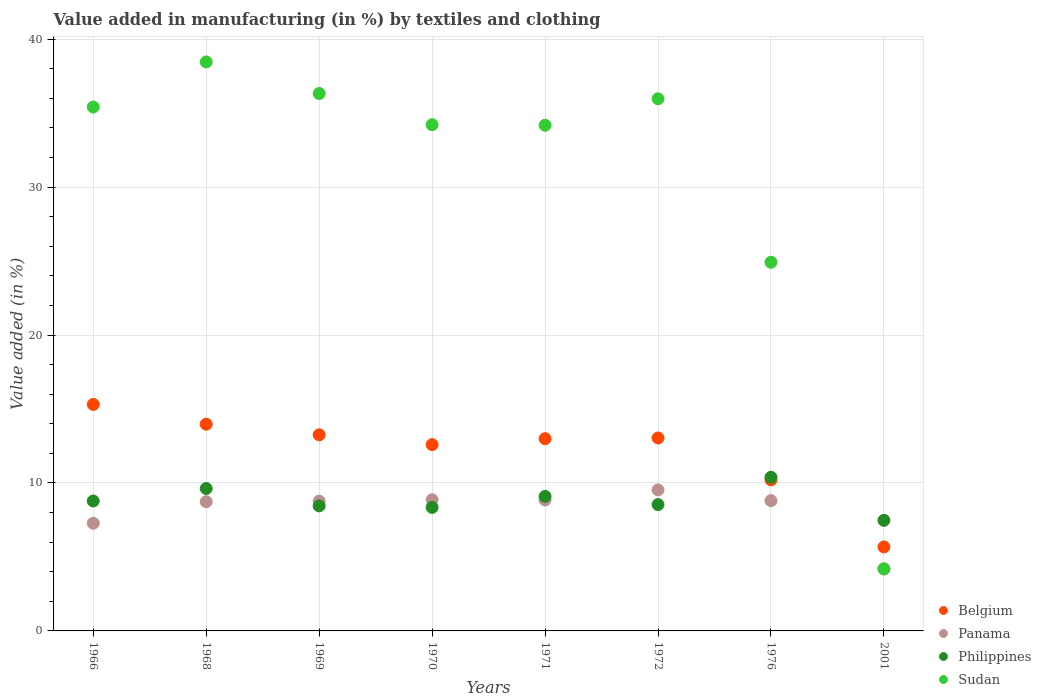What is the percentage of value added in manufacturing by textiles and clothing in Panama in 1970?
Make the answer very short. 8.87. Across all years, what is the maximum percentage of value added in manufacturing by textiles and clothing in Sudan?
Your answer should be very brief. 38.46. Across all years, what is the minimum percentage of value added in manufacturing by textiles and clothing in Belgium?
Your answer should be very brief. 5.68. In which year was the percentage of value added in manufacturing by textiles and clothing in Belgium maximum?
Provide a succinct answer. 1966. In which year was the percentage of value added in manufacturing by textiles and clothing in Sudan minimum?
Provide a short and direct response. 2001. What is the total percentage of value added in manufacturing by textiles and clothing in Philippines in the graph?
Keep it short and to the point. 70.7. What is the difference between the percentage of value added in manufacturing by textiles and clothing in Philippines in 1970 and that in 2001?
Provide a short and direct response. 0.88. What is the difference between the percentage of value added in manufacturing by textiles and clothing in Sudan in 1976 and the percentage of value added in manufacturing by textiles and clothing in Panama in 1970?
Your answer should be very brief. 16.05. What is the average percentage of value added in manufacturing by textiles and clothing in Philippines per year?
Provide a succinct answer. 8.84. In the year 1968, what is the difference between the percentage of value added in manufacturing by textiles and clothing in Panama and percentage of value added in manufacturing by textiles and clothing in Belgium?
Offer a very short reply. -5.24. In how many years, is the percentage of value added in manufacturing by textiles and clothing in Philippines greater than 16 %?
Offer a very short reply. 0. What is the ratio of the percentage of value added in manufacturing by textiles and clothing in Philippines in 1968 to that in 1969?
Make the answer very short. 1.14. Is the percentage of value added in manufacturing by textiles and clothing in Belgium in 1970 less than that in 1971?
Provide a succinct answer. Yes. Is the difference between the percentage of value added in manufacturing by textiles and clothing in Panama in 1968 and 2001 greater than the difference between the percentage of value added in manufacturing by textiles and clothing in Belgium in 1968 and 2001?
Ensure brevity in your answer.  No. What is the difference between the highest and the second highest percentage of value added in manufacturing by textiles and clothing in Belgium?
Provide a short and direct response. 1.33. What is the difference between the highest and the lowest percentage of value added in manufacturing by textiles and clothing in Philippines?
Provide a succinct answer. 2.91. In how many years, is the percentage of value added in manufacturing by textiles and clothing in Belgium greater than the average percentage of value added in manufacturing by textiles and clothing in Belgium taken over all years?
Your answer should be very brief. 6. Is it the case that in every year, the sum of the percentage of value added in manufacturing by textiles and clothing in Sudan and percentage of value added in manufacturing by textiles and clothing in Belgium  is greater than the sum of percentage of value added in manufacturing by textiles and clothing in Panama and percentage of value added in manufacturing by textiles and clothing in Philippines?
Make the answer very short. No. Is it the case that in every year, the sum of the percentage of value added in manufacturing by textiles and clothing in Sudan and percentage of value added in manufacturing by textiles and clothing in Panama  is greater than the percentage of value added in manufacturing by textiles and clothing in Philippines?
Your response must be concise. Yes. Is the percentage of value added in manufacturing by textiles and clothing in Philippines strictly greater than the percentage of value added in manufacturing by textiles and clothing in Belgium over the years?
Keep it short and to the point. No. Is the percentage of value added in manufacturing by textiles and clothing in Panama strictly less than the percentage of value added in manufacturing by textiles and clothing in Philippines over the years?
Provide a short and direct response. No. How many dotlines are there?
Offer a terse response. 4. Are the values on the major ticks of Y-axis written in scientific E-notation?
Make the answer very short. No. What is the title of the graph?
Give a very brief answer. Value added in manufacturing (in %) by textiles and clothing. Does "Netherlands" appear as one of the legend labels in the graph?
Offer a terse response. No. What is the label or title of the Y-axis?
Provide a succinct answer. Value added (in %). What is the Value added (in %) of Belgium in 1966?
Provide a succinct answer. 15.31. What is the Value added (in %) of Panama in 1966?
Provide a succinct answer. 7.28. What is the Value added (in %) in Philippines in 1966?
Provide a short and direct response. 8.78. What is the Value added (in %) of Sudan in 1966?
Your answer should be very brief. 35.41. What is the Value added (in %) of Belgium in 1968?
Provide a short and direct response. 13.97. What is the Value added (in %) in Panama in 1968?
Provide a succinct answer. 8.73. What is the Value added (in %) in Philippines in 1968?
Your answer should be compact. 9.63. What is the Value added (in %) of Sudan in 1968?
Make the answer very short. 38.46. What is the Value added (in %) in Belgium in 1969?
Provide a succinct answer. 13.26. What is the Value added (in %) of Panama in 1969?
Ensure brevity in your answer.  8.77. What is the Value added (in %) of Philippines in 1969?
Offer a terse response. 8.45. What is the Value added (in %) of Sudan in 1969?
Give a very brief answer. 36.32. What is the Value added (in %) of Belgium in 1970?
Ensure brevity in your answer.  12.59. What is the Value added (in %) in Panama in 1970?
Offer a very short reply. 8.87. What is the Value added (in %) in Philippines in 1970?
Keep it short and to the point. 8.35. What is the Value added (in %) in Sudan in 1970?
Keep it short and to the point. 34.21. What is the Value added (in %) in Belgium in 1971?
Provide a short and direct response. 12.99. What is the Value added (in %) in Panama in 1971?
Provide a succinct answer. 8.85. What is the Value added (in %) in Philippines in 1971?
Provide a succinct answer. 9.09. What is the Value added (in %) of Sudan in 1971?
Provide a short and direct response. 34.18. What is the Value added (in %) in Belgium in 1972?
Provide a short and direct response. 13.04. What is the Value added (in %) of Panama in 1972?
Offer a terse response. 9.53. What is the Value added (in %) in Philippines in 1972?
Ensure brevity in your answer.  8.54. What is the Value added (in %) of Sudan in 1972?
Offer a very short reply. 35.97. What is the Value added (in %) of Belgium in 1976?
Your response must be concise. 10.22. What is the Value added (in %) in Panama in 1976?
Offer a terse response. 8.8. What is the Value added (in %) in Philippines in 1976?
Offer a very short reply. 10.39. What is the Value added (in %) of Sudan in 1976?
Provide a short and direct response. 24.92. What is the Value added (in %) of Belgium in 2001?
Your response must be concise. 5.68. What is the Value added (in %) of Panama in 2001?
Keep it short and to the point. 4.19. What is the Value added (in %) of Philippines in 2001?
Your answer should be very brief. 7.47. What is the Value added (in %) of Sudan in 2001?
Your answer should be very brief. 4.19. Across all years, what is the maximum Value added (in %) of Belgium?
Make the answer very short. 15.31. Across all years, what is the maximum Value added (in %) in Panama?
Give a very brief answer. 9.53. Across all years, what is the maximum Value added (in %) in Philippines?
Your answer should be very brief. 10.39. Across all years, what is the maximum Value added (in %) of Sudan?
Your answer should be very brief. 38.46. Across all years, what is the minimum Value added (in %) in Belgium?
Your answer should be compact. 5.68. Across all years, what is the minimum Value added (in %) in Panama?
Your response must be concise. 4.19. Across all years, what is the minimum Value added (in %) of Philippines?
Make the answer very short. 7.47. Across all years, what is the minimum Value added (in %) in Sudan?
Your answer should be compact. 4.19. What is the total Value added (in %) in Belgium in the graph?
Your answer should be compact. 97.06. What is the total Value added (in %) in Panama in the graph?
Make the answer very short. 65.02. What is the total Value added (in %) of Philippines in the graph?
Ensure brevity in your answer.  70.7. What is the total Value added (in %) in Sudan in the graph?
Your answer should be very brief. 243.67. What is the difference between the Value added (in %) in Belgium in 1966 and that in 1968?
Offer a terse response. 1.33. What is the difference between the Value added (in %) in Panama in 1966 and that in 1968?
Your answer should be very brief. -1.45. What is the difference between the Value added (in %) of Philippines in 1966 and that in 1968?
Keep it short and to the point. -0.84. What is the difference between the Value added (in %) of Sudan in 1966 and that in 1968?
Your answer should be very brief. -3.05. What is the difference between the Value added (in %) in Belgium in 1966 and that in 1969?
Offer a terse response. 2.05. What is the difference between the Value added (in %) in Panama in 1966 and that in 1969?
Provide a succinct answer. -1.49. What is the difference between the Value added (in %) of Philippines in 1966 and that in 1969?
Offer a terse response. 0.33. What is the difference between the Value added (in %) of Sudan in 1966 and that in 1969?
Offer a terse response. -0.92. What is the difference between the Value added (in %) of Belgium in 1966 and that in 1970?
Provide a short and direct response. 2.72. What is the difference between the Value added (in %) of Panama in 1966 and that in 1970?
Offer a very short reply. -1.59. What is the difference between the Value added (in %) in Philippines in 1966 and that in 1970?
Make the answer very short. 0.43. What is the difference between the Value added (in %) in Sudan in 1966 and that in 1970?
Your answer should be very brief. 1.19. What is the difference between the Value added (in %) in Belgium in 1966 and that in 1971?
Provide a succinct answer. 2.31. What is the difference between the Value added (in %) in Panama in 1966 and that in 1971?
Your response must be concise. -1.57. What is the difference between the Value added (in %) of Philippines in 1966 and that in 1971?
Make the answer very short. -0.31. What is the difference between the Value added (in %) of Sudan in 1966 and that in 1971?
Make the answer very short. 1.23. What is the difference between the Value added (in %) in Belgium in 1966 and that in 1972?
Give a very brief answer. 2.27. What is the difference between the Value added (in %) of Panama in 1966 and that in 1972?
Keep it short and to the point. -2.26. What is the difference between the Value added (in %) in Philippines in 1966 and that in 1972?
Make the answer very short. 0.24. What is the difference between the Value added (in %) of Sudan in 1966 and that in 1972?
Provide a short and direct response. -0.56. What is the difference between the Value added (in %) in Belgium in 1966 and that in 1976?
Ensure brevity in your answer.  5.09. What is the difference between the Value added (in %) in Panama in 1966 and that in 1976?
Your answer should be very brief. -1.53. What is the difference between the Value added (in %) in Philippines in 1966 and that in 1976?
Your response must be concise. -1.61. What is the difference between the Value added (in %) in Sudan in 1966 and that in 1976?
Keep it short and to the point. 10.49. What is the difference between the Value added (in %) in Belgium in 1966 and that in 2001?
Ensure brevity in your answer.  9.63. What is the difference between the Value added (in %) of Panama in 1966 and that in 2001?
Offer a terse response. 3.09. What is the difference between the Value added (in %) in Philippines in 1966 and that in 2001?
Ensure brevity in your answer.  1.31. What is the difference between the Value added (in %) of Sudan in 1966 and that in 2001?
Give a very brief answer. 31.22. What is the difference between the Value added (in %) of Belgium in 1968 and that in 1969?
Keep it short and to the point. 0.72. What is the difference between the Value added (in %) in Panama in 1968 and that in 1969?
Your answer should be compact. -0.04. What is the difference between the Value added (in %) of Philippines in 1968 and that in 1969?
Keep it short and to the point. 1.17. What is the difference between the Value added (in %) of Sudan in 1968 and that in 1969?
Keep it short and to the point. 2.14. What is the difference between the Value added (in %) in Belgium in 1968 and that in 1970?
Your answer should be very brief. 1.38. What is the difference between the Value added (in %) in Panama in 1968 and that in 1970?
Your answer should be compact. -0.14. What is the difference between the Value added (in %) in Philippines in 1968 and that in 1970?
Keep it short and to the point. 1.28. What is the difference between the Value added (in %) in Sudan in 1968 and that in 1970?
Ensure brevity in your answer.  4.24. What is the difference between the Value added (in %) in Belgium in 1968 and that in 1971?
Offer a terse response. 0.98. What is the difference between the Value added (in %) in Panama in 1968 and that in 1971?
Make the answer very short. -0.12. What is the difference between the Value added (in %) in Philippines in 1968 and that in 1971?
Your answer should be compact. 0.53. What is the difference between the Value added (in %) of Sudan in 1968 and that in 1971?
Offer a very short reply. 4.28. What is the difference between the Value added (in %) in Belgium in 1968 and that in 1972?
Provide a succinct answer. 0.93. What is the difference between the Value added (in %) of Panama in 1968 and that in 1972?
Your response must be concise. -0.8. What is the difference between the Value added (in %) in Philippines in 1968 and that in 1972?
Your response must be concise. 1.09. What is the difference between the Value added (in %) in Sudan in 1968 and that in 1972?
Ensure brevity in your answer.  2.49. What is the difference between the Value added (in %) of Belgium in 1968 and that in 1976?
Ensure brevity in your answer.  3.76. What is the difference between the Value added (in %) in Panama in 1968 and that in 1976?
Offer a terse response. -0.07. What is the difference between the Value added (in %) of Philippines in 1968 and that in 1976?
Keep it short and to the point. -0.76. What is the difference between the Value added (in %) of Sudan in 1968 and that in 1976?
Your answer should be very brief. 13.54. What is the difference between the Value added (in %) in Belgium in 1968 and that in 2001?
Ensure brevity in your answer.  8.3. What is the difference between the Value added (in %) in Panama in 1968 and that in 2001?
Provide a short and direct response. 4.54. What is the difference between the Value added (in %) of Philippines in 1968 and that in 2001?
Your answer should be compact. 2.15. What is the difference between the Value added (in %) of Sudan in 1968 and that in 2001?
Your response must be concise. 34.27. What is the difference between the Value added (in %) in Belgium in 1969 and that in 1970?
Make the answer very short. 0.66. What is the difference between the Value added (in %) in Panama in 1969 and that in 1970?
Ensure brevity in your answer.  -0.1. What is the difference between the Value added (in %) of Philippines in 1969 and that in 1970?
Offer a terse response. 0.1. What is the difference between the Value added (in %) in Sudan in 1969 and that in 1970?
Keep it short and to the point. 2.11. What is the difference between the Value added (in %) in Belgium in 1969 and that in 1971?
Give a very brief answer. 0.26. What is the difference between the Value added (in %) of Panama in 1969 and that in 1971?
Make the answer very short. -0.08. What is the difference between the Value added (in %) in Philippines in 1969 and that in 1971?
Your answer should be compact. -0.64. What is the difference between the Value added (in %) in Sudan in 1969 and that in 1971?
Offer a terse response. 2.14. What is the difference between the Value added (in %) in Belgium in 1969 and that in 1972?
Ensure brevity in your answer.  0.22. What is the difference between the Value added (in %) in Panama in 1969 and that in 1972?
Provide a succinct answer. -0.76. What is the difference between the Value added (in %) of Philippines in 1969 and that in 1972?
Keep it short and to the point. -0.09. What is the difference between the Value added (in %) of Sudan in 1969 and that in 1972?
Give a very brief answer. 0.36. What is the difference between the Value added (in %) of Belgium in 1969 and that in 1976?
Your answer should be compact. 3.04. What is the difference between the Value added (in %) of Panama in 1969 and that in 1976?
Provide a short and direct response. -0.03. What is the difference between the Value added (in %) in Philippines in 1969 and that in 1976?
Your response must be concise. -1.94. What is the difference between the Value added (in %) in Sudan in 1969 and that in 1976?
Offer a terse response. 11.41. What is the difference between the Value added (in %) of Belgium in 1969 and that in 2001?
Make the answer very short. 7.58. What is the difference between the Value added (in %) of Panama in 1969 and that in 2001?
Provide a succinct answer. 4.58. What is the difference between the Value added (in %) of Philippines in 1969 and that in 2001?
Ensure brevity in your answer.  0.98. What is the difference between the Value added (in %) in Sudan in 1969 and that in 2001?
Provide a succinct answer. 32.13. What is the difference between the Value added (in %) of Belgium in 1970 and that in 1971?
Keep it short and to the point. -0.4. What is the difference between the Value added (in %) of Panama in 1970 and that in 1971?
Make the answer very short. 0.02. What is the difference between the Value added (in %) in Philippines in 1970 and that in 1971?
Your answer should be very brief. -0.74. What is the difference between the Value added (in %) in Sudan in 1970 and that in 1971?
Keep it short and to the point. 0.03. What is the difference between the Value added (in %) in Belgium in 1970 and that in 1972?
Ensure brevity in your answer.  -0.45. What is the difference between the Value added (in %) in Panama in 1970 and that in 1972?
Offer a very short reply. -0.67. What is the difference between the Value added (in %) of Philippines in 1970 and that in 1972?
Provide a short and direct response. -0.19. What is the difference between the Value added (in %) in Sudan in 1970 and that in 1972?
Your answer should be very brief. -1.75. What is the difference between the Value added (in %) of Belgium in 1970 and that in 1976?
Your answer should be very brief. 2.38. What is the difference between the Value added (in %) of Panama in 1970 and that in 1976?
Your answer should be compact. 0.06. What is the difference between the Value added (in %) in Philippines in 1970 and that in 1976?
Ensure brevity in your answer.  -2.04. What is the difference between the Value added (in %) in Sudan in 1970 and that in 1976?
Provide a short and direct response. 9.3. What is the difference between the Value added (in %) in Belgium in 1970 and that in 2001?
Your answer should be very brief. 6.92. What is the difference between the Value added (in %) in Panama in 1970 and that in 2001?
Make the answer very short. 4.68. What is the difference between the Value added (in %) of Philippines in 1970 and that in 2001?
Offer a terse response. 0.88. What is the difference between the Value added (in %) in Sudan in 1970 and that in 2001?
Provide a short and direct response. 30.02. What is the difference between the Value added (in %) of Belgium in 1971 and that in 1972?
Your response must be concise. -0.05. What is the difference between the Value added (in %) in Panama in 1971 and that in 1972?
Give a very brief answer. -0.68. What is the difference between the Value added (in %) in Philippines in 1971 and that in 1972?
Provide a succinct answer. 0.55. What is the difference between the Value added (in %) of Sudan in 1971 and that in 1972?
Provide a short and direct response. -1.79. What is the difference between the Value added (in %) in Belgium in 1971 and that in 1976?
Make the answer very short. 2.78. What is the difference between the Value added (in %) of Panama in 1971 and that in 1976?
Your answer should be very brief. 0.04. What is the difference between the Value added (in %) in Philippines in 1971 and that in 1976?
Your answer should be very brief. -1.29. What is the difference between the Value added (in %) of Sudan in 1971 and that in 1976?
Make the answer very short. 9.26. What is the difference between the Value added (in %) of Belgium in 1971 and that in 2001?
Make the answer very short. 7.32. What is the difference between the Value added (in %) of Panama in 1971 and that in 2001?
Your response must be concise. 4.66. What is the difference between the Value added (in %) in Philippines in 1971 and that in 2001?
Your response must be concise. 1.62. What is the difference between the Value added (in %) in Sudan in 1971 and that in 2001?
Your answer should be compact. 29.99. What is the difference between the Value added (in %) of Belgium in 1972 and that in 1976?
Offer a very short reply. 2.83. What is the difference between the Value added (in %) of Panama in 1972 and that in 1976?
Offer a very short reply. 0.73. What is the difference between the Value added (in %) in Philippines in 1972 and that in 1976?
Your answer should be very brief. -1.85. What is the difference between the Value added (in %) of Sudan in 1972 and that in 1976?
Provide a short and direct response. 11.05. What is the difference between the Value added (in %) in Belgium in 1972 and that in 2001?
Your answer should be compact. 7.36. What is the difference between the Value added (in %) in Panama in 1972 and that in 2001?
Keep it short and to the point. 5.34. What is the difference between the Value added (in %) of Philippines in 1972 and that in 2001?
Make the answer very short. 1.07. What is the difference between the Value added (in %) in Sudan in 1972 and that in 2001?
Your answer should be very brief. 31.77. What is the difference between the Value added (in %) of Belgium in 1976 and that in 2001?
Keep it short and to the point. 4.54. What is the difference between the Value added (in %) in Panama in 1976 and that in 2001?
Ensure brevity in your answer.  4.61. What is the difference between the Value added (in %) in Philippines in 1976 and that in 2001?
Your answer should be compact. 2.91. What is the difference between the Value added (in %) in Sudan in 1976 and that in 2001?
Your response must be concise. 20.72. What is the difference between the Value added (in %) of Belgium in 1966 and the Value added (in %) of Panama in 1968?
Make the answer very short. 6.58. What is the difference between the Value added (in %) in Belgium in 1966 and the Value added (in %) in Philippines in 1968?
Your answer should be very brief. 5.68. What is the difference between the Value added (in %) of Belgium in 1966 and the Value added (in %) of Sudan in 1968?
Your answer should be compact. -23.15. What is the difference between the Value added (in %) of Panama in 1966 and the Value added (in %) of Philippines in 1968?
Give a very brief answer. -2.35. What is the difference between the Value added (in %) in Panama in 1966 and the Value added (in %) in Sudan in 1968?
Keep it short and to the point. -31.18. What is the difference between the Value added (in %) in Philippines in 1966 and the Value added (in %) in Sudan in 1968?
Offer a very short reply. -29.68. What is the difference between the Value added (in %) in Belgium in 1966 and the Value added (in %) in Panama in 1969?
Your response must be concise. 6.54. What is the difference between the Value added (in %) in Belgium in 1966 and the Value added (in %) in Philippines in 1969?
Provide a short and direct response. 6.86. What is the difference between the Value added (in %) in Belgium in 1966 and the Value added (in %) in Sudan in 1969?
Your answer should be compact. -21.02. What is the difference between the Value added (in %) of Panama in 1966 and the Value added (in %) of Philippines in 1969?
Offer a terse response. -1.17. What is the difference between the Value added (in %) of Panama in 1966 and the Value added (in %) of Sudan in 1969?
Offer a terse response. -29.05. What is the difference between the Value added (in %) of Philippines in 1966 and the Value added (in %) of Sudan in 1969?
Provide a short and direct response. -27.54. What is the difference between the Value added (in %) of Belgium in 1966 and the Value added (in %) of Panama in 1970?
Keep it short and to the point. 6.44. What is the difference between the Value added (in %) in Belgium in 1966 and the Value added (in %) in Philippines in 1970?
Give a very brief answer. 6.96. What is the difference between the Value added (in %) in Belgium in 1966 and the Value added (in %) in Sudan in 1970?
Offer a terse response. -18.91. What is the difference between the Value added (in %) in Panama in 1966 and the Value added (in %) in Philippines in 1970?
Keep it short and to the point. -1.07. What is the difference between the Value added (in %) of Panama in 1966 and the Value added (in %) of Sudan in 1970?
Offer a terse response. -26.94. What is the difference between the Value added (in %) of Philippines in 1966 and the Value added (in %) of Sudan in 1970?
Provide a succinct answer. -25.43. What is the difference between the Value added (in %) of Belgium in 1966 and the Value added (in %) of Panama in 1971?
Offer a terse response. 6.46. What is the difference between the Value added (in %) of Belgium in 1966 and the Value added (in %) of Philippines in 1971?
Keep it short and to the point. 6.22. What is the difference between the Value added (in %) in Belgium in 1966 and the Value added (in %) in Sudan in 1971?
Offer a terse response. -18.87. What is the difference between the Value added (in %) of Panama in 1966 and the Value added (in %) of Philippines in 1971?
Make the answer very short. -1.81. What is the difference between the Value added (in %) in Panama in 1966 and the Value added (in %) in Sudan in 1971?
Offer a very short reply. -26.9. What is the difference between the Value added (in %) in Philippines in 1966 and the Value added (in %) in Sudan in 1971?
Give a very brief answer. -25.4. What is the difference between the Value added (in %) of Belgium in 1966 and the Value added (in %) of Panama in 1972?
Give a very brief answer. 5.78. What is the difference between the Value added (in %) in Belgium in 1966 and the Value added (in %) in Philippines in 1972?
Provide a succinct answer. 6.77. What is the difference between the Value added (in %) of Belgium in 1966 and the Value added (in %) of Sudan in 1972?
Ensure brevity in your answer.  -20.66. What is the difference between the Value added (in %) of Panama in 1966 and the Value added (in %) of Philippines in 1972?
Make the answer very short. -1.26. What is the difference between the Value added (in %) in Panama in 1966 and the Value added (in %) in Sudan in 1972?
Give a very brief answer. -28.69. What is the difference between the Value added (in %) in Philippines in 1966 and the Value added (in %) in Sudan in 1972?
Provide a short and direct response. -27.19. What is the difference between the Value added (in %) in Belgium in 1966 and the Value added (in %) in Panama in 1976?
Provide a short and direct response. 6.5. What is the difference between the Value added (in %) in Belgium in 1966 and the Value added (in %) in Philippines in 1976?
Your response must be concise. 4.92. What is the difference between the Value added (in %) of Belgium in 1966 and the Value added (in %) of Sudan in 1976?
Your response must be concise. -9.61. What is the difference between the Value added (in %) in Panama in 1966 and the Value added (in %) in Philippines in 1976?
Your answer should be compact. -3.11. What is the difference between the Value added (in %) in Panama in 1966 and the Value added (in %) in Sudan in 1976?
Give a very brief answer. -17.64. What is the difference between the Value added (in %) of Philippines in 1966 and the Value added (in %) of Sudan in 1976?
Your answer should be very brief. -16.14. What is the difference between the Value added (in %) of Belgium in 1966 and the Value added (in %) of Panama in 2001?
Provide a succinct answer. 11.12. What is the difference between the Value added (in %) of Belgium in 1966 and the Value added (in %) of Philippines in 2001?
Give a very brief answer. 7.84. What is the difference between the Value added (in %) of Belgium in 1966 and the Value added (in %) of Sudan in 2001?
Give a very brief answer. 11.11. What is the difference between the Value added (in %) of Panama in 1966 and the Value added (in %) of Philippines in 2001?
Your response must be concise. -0.2. What is the difference between the Value added (in %) in Panama in 1966 and the Value added (in %) in Sudan in 2001?
Provide a short and direct response. 3.08. What is the difference between the Value added (in %) of Philippines in 1966 and the Value added (in %) of Sudan in 2001?
Make the answer very short. 4.59. What is the difference between the Value added (in %) in Belgium in 1968 and the Value added (in %) in Panama in 1969?
Give a very brief answer. 5.2. What is the difference between the Value added (in %) of Belgium in 1968 and the Value added (in %) of Philippines in 1969?
Provide a succinct answer. 5.52. What is the difference between the Value added (in %) in Belgium in 1968 and the Value added (in %) in Sudan in 1969?
Your response must be concise. -22.35. What is the difference between the Value added (in %) of Panama in 1968 and the Value added (in %) of Philippines in 1969?
Your response must be concise. 0.28. What is the difference between the Value added (in %) in Panama in 1968 and the Value added (in %) in Sudan in 1969?
Ensure brevity in your answer.  -27.59. What is the difference between the Value added (in %) in Philippines in 1968 and the Value added (in %) in Sudan in 1969?
Give a very brief answer. -26.7. What is the difference between the Value added (in %) of Belgium in 1968 and the Value added (in %) of Panama in 1970?
Ensure brevity in your answer.  5.11. What is the difference between the Value added (in %) in Belgium in 1968 and the Value added (in %) in Philippines in 1970?
Your answer should be very brief. 5.62. What is the difference between the Value added (in %) in Belgium in 1968 and the Value added (in %) in Sudan in 1970?
Your answer should be very brief. -20.24. What is the difference between the Value added (in %) in Panama in 1968 and the Value added (in %) in Philippines in 1970?
Give a very brief answer. 0.38. What is the difference between the Value added (in %) in Panama in 1968 and the Value added (in %) in Sudan in 1970?
Your answer should be very brief. -25.48. What is the difference between the Value added (in %) of Philippines in 1968 and the Value added (in %) of Sudan in 1970?
Keep it short and to the point. -24.59. What is the difference between the Value added (in %) of Belgium in 1968 and the Value added (in %) of Panama in 1971?
Keep it short and to the point. 5.13. What is the difference between the Value added (in %) in Belgium in 1968 and the Value added (in %) in Philippines in 1971?
Keep it short and to the point. 4.88. What is the difference between the Value added (in %) in Belgium in 1968 and the Value added (in %) in Sudan in 1971?
Offer a very short reply. -20.21. What is the difference between the Value added (in %) of Panama in 1968 and the Value added (in %) of Philippines in 1971?
Give a very brief answer. -0.36. What is the difference between the Value added (in %) of Panama in 1968 and the Value added (in %) of Sudan in 1971?
Ensure brevity in your answer.  -25.45. What is the difference between the Value added (in %) of Philippines in 1968 and the Value added (in %) of Sudan in 1971?
Your answer should be very brief. -24.55. What is the difference between the Value added (in %) in Belgium in 1968 and the Value added (in %) in Panama in 1972?
Keep it short and to the point. 4.44. What is the difference between the Value added (in %) in Belgium in 1968 and the Value added (in %) in Philippines in 1972?
Keep it short and to the point. 5.43. What is the difference between the Value added (in %) in Belgium in 1968 and the Value added (in %) in Sudan in 1972?
Your response must be concise. -21.99. What is the difference between the Value added (in %) in Panama in 1968 and the Value added (in %) in Philippines in 1972?
Give a very brief answer. 0.19. What is the difference between the Value added (in %) in Panama in 1968 and the Value added (in %) in Sudan in 1972?
Your answer should be compact. -27.24. What is the difference between the Value added (in %) of Philippines in 1968 and the Value added (in %) of Sudan in 1972?
Provide a short and direct response. -26.34. What is the difference between the Value added (in %) of Belgium in 1968 and the Value added (in %) of Panama in 1976?
Your answer should be very brief. 5.17. What is the difference between the Value added (in %) in Belgium in 1968 and the Value added (in %) in Philippines in 1976?
Your answer should be compact. 3.59. What is the difference between the Value added (in %) of Belgium in 1968 and the Value added (in %) of Sudan in 1976?
Give a very brief answer. -10.94. What is the difference between the Value added (in %) of Panama in 1968 and the Value added (in %) of Philippines in 1976?
Offer a very short reply. -1.66. What is the difference between the Value added (in %) in Panama in 1968 and the Value added (in %) in Sudan in 1976?
Make the answer very short. -16.19. What is the difference between the Value added (in %) of Philippines in 1968 and the Value added (in %) of Sudan in 1976?
Make the answer very short. -15.29. What is the difference between the Value added (in %) in Belgium in 1968 and the Value added (in %) in Panama in 2001?
Provide a short and direct response. 9.78. What is the difference between the Value added (in %) of Belgium in 1968 and the Value added (in %) of Philippines in 2001?
Provide a succinct answer. 6.5. What is the difference between the Value added (in %) in Belgium in 1968 and the Value added (in %) in Sudan in 2001?
Your answer should be very brief. 9.78. What is the difference between the Value added (in %) of Panama in 1968 and the Value added (in %) of Philippines in 2001?
Offer a very short reply. 1.26. What is the difference between the Value added (in %) in Panama in 1968 and the Value added (in %) in Sudan in 2001?
Make the answer very short. 4.54. What is the difference between the Value added (in %) of Philippines in 1968 and the Value added (in %) of Sudan in 2001?
Give a very brief answer. 5.43. What is the difference between the Value added (in %) of Belgium in 1969 and the Value added (in %) of Panama in 1970?
Keep it short and to the point. 4.39. What is the difference between the Value added (in %) of Belgium in 1969 and the Value added (in %) of Philippines in 1970?
Provide a short and direct response. 4.91. What is the difference between the Value added (in %) in Belgium in 1969 and the Value added (in %) in Sudan in 1970?
Ensure brevity in your answer.  -20.96. What is the difference between the Value added (in %) in Panama in 1969 and the Value added (in %) in Philippines in 1970?
Offer a very short reply. 0.42. What is the difference between the Value added (in %) in Panama in 1969 and the Value added (in %) in Sudan in 1970?
Your response must be concise. -25.44. What is the difference between the Value added (in %) in Philippines in 1969 and the Value added (in %) in Sudan in 1970?
Make the answer very short. -25.76. What is the difference between the Value added (in %) in Belgium in 1969 and the Value added (in %) in Panama in 1971?
Provide a succinct answer. 4.41. What is the difference between the Value added (in %) of Belgium in 1969 and the Value added (in %) of Philippines in 1971?
Provide a short and direct response. 4.16. What is the difference between the Value added (in %) of Belgium in 1969 and the Value added (in %) of Sudan in 1971?
Your answer should be very brief. -20.92. What is the difference between the Value added (in %) of Panama in 1969 and the Value added (in %) of Philippines in 1971?
Give a very brief answer. -0.32. What is the difference between the Value added (in %) in Panama in 1969 and the Value added (in %) in Sudan in 1971?
Make the answer very short. -25.41. What is the difference between the Value added (in %) of Philippines in 1969 and the Value added (in %) of Sudan in 1971?
Your answer should be very brief. -25.73. What is the difference between the Value added (in %) in Belgium in 1969 and the Value added (in %) in Panama in 1972?
Keep it short and to the point. 3.72. What is the difference between the Value added (in %) of Belgium in 1969 and the Value added (in %) of Philippines in 1972?
Offer a terse response. 4.72. What is the difference between the Value added (in %) in Belgium in 1969 and the Value added (in %) in Sudan in 1972?
Your answer should be compact. -22.71. What is the difference between the Value added (in %) of Panama in 1969 and the Value added (in %) of Philippines in 1972?
Your answer should be compact. 0.23. What is the difference between the Value added (in %) of Panama in 1969 and the Value added (in %) of Sudan in 1972?
Ensure brevity in your answer.  -27.2. What is the difference between the Value added (in %) in Philippines in 1969 and the Value added (in %) in Sudan in 1972?
Provide a succinct answer. -27.52. What is the difference between the Value added (in %) in Belgium in 1969 and the Value added (in %) in Panama in 1976?
Provide a succinct answer. 4.45. What is the difference between the Value added (in %) in Belgium in 1969 and the Value added (in %) in Philippines in 1976?
Provide a short and direct response. 2.87. What is the difference between the Value added (in %) in Belgium in 1969 and the Value added (in %) in Sudan in 1976?
Make the answer very short. -11.66. What is the difference between the Value added (in %) in Panama in 1969 and the Value added (in %) in Philippines in 1976?
Provide a short and direct response. -1.62. What is the difference between the Value added (in %) of Panama in 1969 and the Value added (in %) of Sudan in 1976?
Your answer should be very brief. -16.15. What is the difference between the Value added (in %) of Philippines in 1969 and the Value added (in %) of Sudan in 1976?
Keep it short and to the point. -16.47. What is the difference between the Value added (in %) of Belgium in 1969 and the Value added (in %) of Panama in 2001?
Your answer should be compact. 9.07. What is the difference between the Value added (in %) of Belgium in 1969 and the Value added (in %) of Philippines in 2001?
Provide a succinct answer. 5.78. What is the difference between the Value added (in %) in Belgium in 1969 and the Value added (in %) in Sudan in 2001?
Offer a very short reply. 9.06. What is the difference between the Value added (in %) of Panama in 1969 and the Value added (in %) of Philippines in 2001?
Ensure brevity in your answer.  1.3. What is the difference between the Value added (in %) in Panama in 1969 and the Value added (in %) in Sudan in 2001?
Your answer should be very brief. 4.58. What is the difference between the Value added (in %) in Philippines in 1969 and the Value added (in %) in Sudan in 2001?
Provide a succinct answer. 4.26. What is the difference between the Value added (in %) in Belgium in 1970 and the Value added (in %) in Panama in 1971?
Your answer should be very brief. 3.74. What is the difference between the Value added (in %) of Belgium in 1970 and the Value added (in %) of Philippines in 1971?
Provide a succinct answer. 3.5. What is the difference between the Value added (in %) in Belgium in 1970 and the Value added (in %) in Sudan in 1971?
Ensure brevity in your answer.  -21.59. What is the difference between the Value added (in %) of Panama in 1970 and the Value added (in %) of Philippines in 1971?
Your answer should be compact. -0.23. What is the difference between the Value added (in %) in Panama in 1970 and the Value added (in %) in Sudan in 1971?
Offer a very short reply. -25.31. What is the difference between the Value added (in %) in Philippines in 1970 and the Value added (in %) in Sudan in 1971?
Give a very brief answer. -25.83. What is the difference between the Value added (in %) of Belgium in 1970 and the Value added (in %) of Panama in 1972?
Provide a short and direct response. 3.06. What is the difference between the Value added (in %) of Belgium in 1970 and the Value added (in %) of Philippines in 1972?
Keep it short and to the point. 4.05. What is the difference between the Value added (in %) in Belgium in 1970 and the Value added (in %) in Sudan in 1972?
Offer a very short reply. -23.37. What is the difference between the Value added (in %) of Panama in 1970 and the Value added (in %) of Philippines in 1972?
Offer a very short reply. 0.33. What is the difference between the Value added (in %) of Panama in 1970 and the Value added (in %) of Sudan in 1972?
Give a very brief answer. -27.1. What is the difference between the Value added (in %) in Philippines in 1970 and the Value added (in %) in Sudan in 1972?
Your response must be concise. -27.62. What is the difference between the Value added (in %) in Belgium in 1970 and the Value added (in %) in Panama in 1976?
Your answer should be very brief. 3.79. What is the difference between the Value added (in %) in Belgium in 1970 and the Value added (in %) in Philippines in 1976?
Provide a succinct answer. 2.21. What is the difference between the Value added (in %) of Belgium in 1970 and the Value added (in %) of Sudan in 1976?
Your answer should be compact. -12.32. What is the difference between the Value added (in %) of Panama in 1970 and the Value added (in %) of Philippines in 1976?
Provide a short and direct response. -1.52. What is the difference between the Value added (in %) of Panama in 1970 and the Value added (in %) of Sudan in 1976?
Ensure brevity in your answer.  -16.05. What is the difference between the Value added (in %) in Philippines in 1970 and the Value added (in %) in Sudan in 1976?
Provide a succinct answer. -16.57. What is the difference between the Value added (in %) of Belgium in 1970 and the Value added (in %) of Panama in 2001?
Make the answer very short. 8.4. What is the difference between the Value added (in %) of Belgium in 1970 and the Value added (in %) of Philippines in 2001?
Ensure brevity in your answer.  5.12. What is the difference between the Value added (in %) of Belgium in 1970 and the Value added (in %) of Sudan in 2001?
Offer a very short reply. 8.4. What is the difference between the Value added (in %) in Panama in 1970 and the Value added (in %) in Philippines in 2001?
Give a very brief answer. 1.39. What is the difference between the Value added (in %) of Panama in 1970 and the Value added (in %) of Sudan in 2001?
Make the answer very short. 4.67. What is the difference between the Value added (in %) in Philippines in 1970 and the Value added (in %) in Sudan in 2001?
Ensure brevity in your answer.  4.16. What is the difference between the Value added (in %) in Belgium in 1971 and the Value added (in %) in Panama in 1972?
Your response must be concise. 3.46. What is the difference between the Value added (in %) of Belgium in 1971 and the Value added (in %) of Philippines in 1972?
Offer a terse response. 4.45. What is the difference between the Value added (in %) in Belgium in 1971 and the Value added (in %) in Sudan in 1972?
Your response must be concise. -22.97. What is the difference between the Value added (in %) in Panama in 1971 and the Value added (in %) in Philippines in 1972?
Ensure brevity in your answer.  0.31. What is the difference between the Value added (in %) in Panama in 1971 and the Value added (in %) in Sudan in 1972?
Offer a very short reply. -27.12. What is the difference between the Value added (in %) of Philippines in 1971 and the Value added (in %) of Sudan in 1972?
Your response must be concise. -26.87. What is the difference between the Value added (in %) in Belgium in 1971 and the Value added (in %) in Panama in 1976?
Give a very brief answer. 4.19. What is the difference between the Value added (in %) in Belgium in 1971 and the Value added (in %) in Philippines in 1976?
Provide a succinct answer. 2.61. What is the difference between the Value added (in %) of Belgium in 1971 and the Value added (in %) of Sudan in 1976?
Ensure brevity in your answer.  -11.92. What is the difference between the Value added (in %) of Panama in 1971 and the Value added (in %) of Philippines in 1976?
Make the answer very short. -1.54. What is the difference between the Value added (in %) of Panama in 1971 and the Value added (in %) of Sudan in 1976?
Your response must be concise. -16.07. What is the difference between the Value added (in %) in Philippines in 1971 and the Value added (in %) in Sudan in 1976?
Keep it short and to the point. -15.82. What is the difference between the Value added (in %) of Belgium in 1971 and the Value added (in %) of Panama in 2001?
Your response must be concise. 8.8. What is the difference between the Value added (in %) of Belgium in 1971 and the Value added (in %) of Philippines in 2001?
Make the answer very short. 5.52. What is the difference between the Value added (in %) of Belgium in 1971 and the Value added (in %) of Sudan in 2001?
Give a very brief answer. 8.8. What is the difference between the Value added (in %) in Panama in 1971 and the Value added (in %) in Philippines in 2001?
Provide a succinct answer. 1.38. What is the difference between the Value added (in %) of Panama in 1971 and the Value added (in %) of Sudan in 2001?
Your response must be concise. 4.65. What is the difference between the Value added (in %) in Philippines in 1971 and the Value added (in %) in Sudan in 2001?
Offer a terse response. 4.9. What is the difference between the Value added (in %) in Belgium in 1972 and the Value added (in %) in Panama in 1976?
Make the answer very short. 4.24. What is the difference between the Value added (in %) of Belgium in 1972 and the Value added (in %) of Philippines in 1976?
Give a very brief answer. 2.65. What is the difference between the Value added (in %) in Belgium in 1972 and the Value added (in %) in Sudan in 1976?
Give a very brief answer. -11.88. What is the difference between the Value added (in %) in Panama in 1972 and the Value added (in %) in Philippines in 1976?
Give a very brief answer. -0.85. What is the difference between the Value added (in %) in Panama in 1972 and the Value added (in %) in Sudan in 1976?
Offer a terse response. -15.38. What is the difference between the Value added (in %) in Philippines in 1972 and the Value added (in %) in Sudan in 1976?
Your answer should be very brief. -16.38. What is the difference between the Value added (in %) in Belgium in 1972 and the Value added (in %) in Panama in 2001?
Give a very brief answer. 8.85. What is the difference between the Value added (in %) in Belgium in 1972 and the Value added (in %) in Philippines in 2001?
Your response must be concise. 5.57. What is the difference between the Value added (in %) of Belgium in 1972 and the Value added (in %) of Sudan in 2001?
Your response must be concise. 8.85. What is the difference between the Value added (in %) of Panama in 1972 and the Value added (in %) of Philippines in 2001?
Offer a terse response. 2.06. What is the difference between the Value added (in %) of Panama in 1972 and the Value added (in %) of Sudan in 2001?
Offer a very short reply. 5.34. What is the difference between the Value added (in %) of Philippines in 1972 and the Value added (in %) of Sudan in 2001?
Give a very brief answer. 4.35. What is the difference between the Value added (in %) in Belgium in 1976 and the Value added (in %) in Panama in 2001?
Provide a short and direct response. 6.02. What is the difference between the Value added (in %) of Belgium in 1976 and the Value added (in %) of Philippines in 2001?
Your answer should be compact. 2.74. What is the difference between the Value added (in %) in Belgium in 1976 and the Value added (in %) in Sudan in 2001?
Keep it short and to the point. 6.02. What is the difference between the Value added (in %) in Panama in 1976 and the Value added (in %) in Philippines in 2001?
Your answer should be very brief. 1.33. What is the difference between the Value added (in %) of Panama in 1976 and the Value added (in %) of Sudan in 2001?
Your answer should be very brief. 4.61. What is the difference between the Value added (in %) in Philippines in 1976 and the Value added (in %) in Sudan in 2001?
Provide a succinct answer. 6.19. What is the average Value added (in %) in Belgium per year?
Your answer should be compact. 12.13. What is the average Value added (in %) of Panama per year?
Your response must be concise. 8.13. What is the average Value added (in %) in Philippines per year?
Your answer should be very brief. 8.84. What is the average Value added (in %) of Sudan per year?
Your answer should be very brief. 30.46. In the year 1966, what is the difference between the Value added (in %) in Belgium and Value added (in %) in Panama?
Offer a terse response. 8.03. In the year 1966, what is the difference between the Value added (in %) of Belgium and Value added (in %) of Philippines?
Give a very brief answer. 6.53. In the year 1966, what is the difference between the Value added (in %) in Belgium and Value added (in %) in Sudan?
Keep it short and to the point. -20.1. In the year 1966, what is the difference between the Value added (in %) of Panama and Value added (in %) of Philippines?
Provide a short and direct response. -1.5. In the year 1966, what is the difference between the Value added (in %) of Panama and Value added (in %) of Sudan?
Your answer should be compact. -28.13. In the year 1966, what is the difference between the Value added (in %) of Philippines and Value added (in %) of Sudan?
Your answer should be compact. -26.63. In the year 1968, what is the difference between the Value added (in %) in Belgium and Value added (in %) in Panama?
Your answer should be very brief. 5.24. In the year 1968, what is the difference between the Value added (in %) in Belgium and Value added (in %) in Philippines?
Offer a very short reply. 4.35. In the year 1968, what is the difference between the Value added (in %) in Belgium and Value added (in %) in Sudan?
Offer a very short reply. -24.49. In the year 1968, what is the difference between the Value added (in %) in Panama and Value added (in %) in Philippines?
Provide a succinct answer. -0.89. In the year 1968, what is the difference between the Value added (in %) of Panama and Value added (in %) of Sudan?
Offer a very short reply. -29.73. In the year 1968, what is the difference between the Value added (in %) in Philippines and Value added (in %) in Sudan?
Provide a short and direct response. -28.83. In the year 1969, what is the difference between the Value added (in %) in Belgium and Value added (in %) in Panama?
Your answer should be very brief. 4.49. In the year 1969, what is the difference between the Value added (in %) of Belgium and Value added (in %) of Philippines?
Keep it short and to the point. 4.81. In the year 1969, what is the difference between the Value added (in %) in Belgium and Value added (in %) in Sudan?
Your answer should be very brief. -23.07. In the year 1969, what is the difference between the Value added (in %) in Panama and Value added (in %) in Philippines?
Give a very brief answer. 0.32. In the year 1969, what is the difference between the Value added (in %) of Panama and Value added (in %) of Sudan?
Your answer should be compact. -27.55. In the year 1969, what is the difference between the Value added (in %) of Philippines and Value added (in %) of Sudan?
Offer a terse response. -27.87. In the year 1970, what is the difference between the Value added (in %) in Belgium and Value added (in %) in Panama?
Provide a short and direct response. 3.73. In the year 1970, what is the difference between the Value added (in %) in Belgium and Value added (in %) in Philippines?
Offer a very short reply. 4.24. In the year 1970, what is the difference between the Value added (in %) in Belgium and Value added (in %) in Sudan?
Ensure brevity in your answer.  -21.62. In the year 1970, what is the difference between the Value added (in %) in Panama and Value added (in %) in Philippines?
Offer a terse response. 0.52. In the year 1970, what is the difference between the Value added (in %) in Panama and Value added (in %) in Sudan?
Provide a succinct answer. -25.35. In the year 1970, what is the difference between the Value added (in %) of Philippines and Value added (in %) of Sudan?
Offer a terse response. -25.87. In the year 1971, what is the difference between the Value added (in %) in Belgium and Value added (in %) in Panama?
Ensure brevity in your answer.  4.15. In the year 1971, what is the difference between the Value added (in %) of Belgium and Value added (in %) of Philippines?
Provide a succinct answer. 3.9. In the year 1971, what is the difference between the Value added (in %) of Belgium and Value added (in %) of Sudan?
Offer a very short reply. -21.19. In the year 1971, what is the difference between the Value added (in %) of Panama and Value added (in %) of Philippines?
Give a very brief answer. -0.24. In the year 1971, what is the difference between the Value added (in %) of Panama and Value added (in %) of Sudan?
Your answer should be very brief. -25.33. In the year 1971, what is the difference between the Value added (in %) in Philippines and Value added (in %) in Sudan?
Make the answer very short. -25.09. In the year 1972, what is the difference between the Value added (in %) of Belgium and Value added (in %) of Panama?
Provide a succinct answer. 3.51. In the year 1972, what is the difference between the Value added (in %) in Belgium and Value added (in %) in Philippines?
Give a very brief answer. 4.5. In the year 1972, what is the difference between the Value added (in %) of Belgium and Value added (in %) of Sudan?
Give a very brief answer. -22.92. In the year 1972, what is the difference between the Value added (in %) in Panama and Value added (in %) in Sudan?
Ensure brevity in your answer.  -26.43. In the year 1972, what is the difference between the Value added (in %) of Philippines and Value added (in %) of Sudan?
Provide a succinct answer. -27.43. In the year 1976, what is the difference between the Value added (in %) of Belgium and Value added (in %) of Panama?
Keep it short and to the point. 1.41. In the year 1976, what is the difference between the Value added (in %) of Belgium and Value added (in %) of Philippines?
Make the answer very short. -0.17. In the year 1976, what is the difference between the Value added (in %) of Belgium and Value added (in %) of Sudan?
Your answer should be very brief. -14.7. In the year 1976, what is the difference between the Value added (in %) in Panama and Value added (in %) in Philippines?
Offer a terse response. -1.58. In the year 1976, what is the difference between the Value added (in %) of Panama and Value added (in %) of Sudan?
Your answer should be compact. -16.11. In the year 1976, what is the difference between the Value added (in %) in Philippines and Value added (in %) in Sudan?
Your answer should be very brief. -14.53. In the year 2001, what is the difference between the Value added (in %) in Belgium and Value added (in %) in Panama?
Offer a very short reply. 1.49. In the year 2001, what is the difference between the Value added (in %) in Belgium and Value added (in %) in Philippines?
Your answer should be very brief. -1.8. In the year 2001, what is the difference between the Value added (in %) in Belgium and Value added (in %) in Sudan?
Your answer should be very brief. 1.48. In the year 2001, what is the difference between the Value added (in %) in Panama and Value added (in %) in Philippines?
Offer a terse response. -3.28. In the year 2001, what is the difference between the Value added (in %) of Panama and Value added (in %) of Sudan?
Make the answer very short. -0. In the year 2001, what is the difference between the Value added (in %) of Philippines and Value added (in %) of Sudan?
Give a very brief answer. 3.28. What is the ratio of the Value added (in %) of Belgium in 1966 to that in 1968?
Make the answer very short. 1.1. What is the ratio of the Value added (in %) in Panama in 1966 to that in 1968?
Ensure brevity in your answer.  0.83. What is the ratio of the Value added (in %) in Philippines in 1966 to that in 1968?
Your answer should be very brief. 0.91. What is the ratio of the Value added (in %) of Sudan in 1966 to that in 1968?
Provide a succinct answer. 0.92. What is the ratio of the Value added (in %) in Belgium in 1966 to that in 1969?
Offer a very short reply. 1.15. What is the ratio of the Value added (in %) in Panama in 1966 to that in 1969?
Ensure brevity in your answer.  0.83. What is the ratio of the Value added (in %) of Philippines in 1966 to that in 1969?
Give a very brief answer. 1.04. What is the ratio of the Value added (in %) in Sudan in 1966 to that in 1969?
Provide a succinct answer. 0.97. What is the ratio of the Value added (in %) of Belgium in 1966 to that in 1970?
Provide a short and direct response. 1.22. What is the ratio of the Value added (in %) of Panama in 1966 to that in 1970?
Your answer should be compact. 0.82. What is the ratio of the Value added (in %) of Philippines in 1966 to that in 1970?
Your response must be concise. 1.05. What is the ratio of the Value added (in %) in Sudan in 1966 to that in 1970?
Offer a terse response. 1.03. What is the ratio of the Value added (in %) of Belgium in 1966 to that in 1971?
Keep it short and to the point. 1.18. What is the ratio of the Value added (in %) in Panama in 1966 to that in 1971?
Offer a very short reply. 0.82. What is the ratio of the Value added (in %) of Philippines in 1966 to that in 1971?
Provide a short and direct response. 0.97. What is the ratio of the Value added (in %) of Sudan in 1966 to that in 1971?
Your answer should be very brief. 1.04. What is the ratio of the Value added (in %) of Belgium in 1966 to that in 1972?
Keep it short and to the point. 1.17. What is the ratio of the Value added (in %) in Panama in 1966 to that in 1972?
Make the answer very short. 0.76. What is the ratio of the Value added (in %) of Philippines in 1966 to that in 1972?
Offer a very short reply. 1.03. What is the ratio of the Value added (in %) in Sudan in 1966 to that in 1972?
Ensure brevity in your answer.  0.98. What is the ratio of the Value added (in %) in Belgium in 1966 to that in 1976?
Make the answer very short. 1.5. What is the ratio of the Value added (in %) in Panama in 1966 to that in 1976?
Offer a very short reply. 0.83. What is the ratio of the Value added (in %) in Philippines in 1966 to that in 1976?
Make the answer very short. 0.85. What is the ratio of the Value added (in %) in Sudan in 1966 to that in 1976?
Your answer should be very brief. 1.42. What is the ratio of the Value added (in %) in Belgium in 1966 to that in 2001?
Keep it short and to the point. 2.7. What is the ratio of the Value added (in %) in Panama in 1966 to that in 2001?
Give a very brief answer. 1.74. What is the ratio of the Value added (in %) of Philippines in 1966 to that in 2001?
Your answer should be very brief. 1.18. What is the ratio of the Value added (in %) in Sudan in 1966 to that in 2001?
Offer a terse response. 8.44. What is the ratio of the Value added (in %) in Belgium in 1968 to that in 1969?
Give a very brief answer. 1.05. What is the ratio of the Value added (in %) in Panama in 1968 to that in 1969?
Keep it short and to the point. 1. What is the ratio of the Value added (in %) of Philippines in 1968 to that in 1969?
Your answer should be very brief. 1.14. What is the ratio of the Value added (in %) in Sudan in 1968 to that in 1969?
Provide a succinct answer. 1.06. What is the ratio of the Value added (in %) of Belgium in 1968 to that in 1970?
Ensure brevity in your answer.  1.11. What is the ratio of the Value added (in %) in Panama in 1968 to that in 1970?
Provide a succinct answer. 0.98. What is the ratio of the Value added (in %) of Philippines in 1968 to that in 1970?
Ensure brevity in your answer.  1.15. What is the ratio of the Value added (in %) in Sudan in 1968 to that in 1970?
Provide a short and direct response. 1.12. What is the ratio of the Value added (in %) of Belgium in 1968 to that in 1971?
Provide a succinct answer. 1.08. What is the ratio of the Value added (in %) in Panama in 1968 to that in 1971?
Give a very brief answer. 0.99. What is the ratio of the Value added (in %) of Philippines in 1968 to that in 1971?
Your response must be concise. 1.06. What is the ratio of the Value added (in %) in Sudan in 1968 to that in 1971?
Make the answer very short. 1.13. What is the ratio of the Value added (in %) in Belgium in 1968 to that in 1972?
Provide a short and direct response. 1.07. What is the ratio of the Value added (in %) in Panama in 1968 to that in 1972?
Provide a short and direct response. 0.92. What is the ratio of the Value added (in %) of Philippines in 1968 to that in 1972?
Make the answer very short. 1.13. What is the ratio of the Value added (in %) of Sudan in 1968 to that in 1972?
Your answer should be very brief. 1.07. What is the ratio of the Value added (in %) of Belgium in 1968 to that in 1976?
Your response must be concise. 1.37. What is the ratio of the Value added (in %) of Philippines in 1968 to that in 1976?
Keep it short and to the point. 0.93. What is the ratio of the Value added (in %) of Sudan in 1968 to that in 1976?
Provide a succinct answer. 1.54. What is the ratio of the Value added (in %) of Belgium in 1968 to that in 2001?
Make the answer very short. 2.46. What is the ratio of the Value added (in %) of Panama in 1968 to that in 2001?
Ensure brevity in your answer.  2.08. What is the ratio of the Value added (in %) in Philippines in 1968 to that in 2001?
Your response must be concise. 1.29. What is the ratio of the Value added (in %) in Sudan in 1968 to that in 2001?
Make the answer very short. 9.17. What is the ratio of the Value added (in %) in Belgium in 1969 to that in 1970?
Keep it short and to the point. 1.05. What is the ratio of the Value added (in %) of Panama in 1969 to that in 1970?
Keep it short and to the point. 0.99. What is the ratio of the Value added (in %) of Philippines in 1969 to that in 1970?
Provide a succinct answer. 1.01. What is the ratio of the Value added (in %) of Sudan in 1969 to that in 1970?
Your answer should be very brief. 1.06. What is the ratio of the Value added (in %) in Belgium in 1969 to that in 1971?
Make the answer very short. 1.02. What is the ratio of the Value added (in %) of Panama in 1969 to that in 1971?
Offer a terse response. 0.99. What is the ratio of the Value added (in %) in Philippines in 1969 to that in 1971?
Provide a short and direct response. 0.93. What is the ratio of the Value added (in %) in Sudan in 1969 to that in 1971?
Provide a succinct answer. 1.06. What is the ratio of the Value added (in %) of Belgium in 1969 to that in 1972?
Give a very brief answer. 1.02. What is the ratio of the Value added (in %) of Panama in 1969 to that in 1972?
Give a very brief answer. 0.92. What is the ratio of the Value added (in %) of Sudan in 1969 to that in 1972?
Offer a terse response. 1.01. What is the ratio of the Value added (in %) of Belgium in 1969 to that in 1976?
Your answer should be very brief. 1.3. What is the ratio of the Value added (in %) of Philippines in 1969 to that in 1976?
Your answer should be very brief. 0.81. What is the ratio of the Value added (in %) in Sudan in 1969 to that in 1976?
Offer a terse response. 1.46. What is the ratio of the Value added (in %) in Belgium in 1969 to that in 2001?
Give a very brief answer. 2.34. What is the ratio of the Value added (in %) of Panama in 1969 to that in 2001?
Offer a terse response. 2.09. What is the ratio of the Value added (in %) in Philippines in 1969 to that in 2001?
Your response must be concise. 1.13. What is the ratio of the Value added (in %) in Sudan in 1969 to that in 2001?
Keep it short and to the point. 8.66. What is the ratio of the Value added (in %) in Belgium in 1970 to that in 1971?
Offer a terse response. 0.97. What is the ratio of the Value added (in %) in Philippines in 1970 to that in 1971?
Offer a very short reply. 0.92. What is the ratio of the Value added (in %) of Sudan in 1970 to that in 1971?
Give a very brief answer. 1. What is the ratio of the Value added (in %) in Belgium in 1970 to that in 1972?
Ensure brevity in your answer.  0.97. What is the ratio of the Value added (in %) of Philippines in 1970 to that in 1972?
Ensure brevity in your answer.  0.98. What is the ratio of the Value added (in %) in Sudan in 1970 to that in 1972?
Provide a succinct answer. 0.95. What is the ratio of the Value added (in %) in Belgium in 1970 to that in 1976?
Offer a terse response. 1.23. What is the ratio of the Value added (in %) in Panama in 1970 to that in 1976?
Offer a very short reply. 1.01. What is the ratio of the Value added (in %) in Philippines in 1970 to that in 1976?
Provide a short and direct response. 0.8. What is the ratio of the Value added (in %) in Sudan in 1970 to that in 1976?
Ensure brevity in your answer.  1.37. What is the ratio of the Value added (in %) in Belgium in 1970 to that in 2001?
Your answer should be very brief. 2.22. What is the ratio of the Value added (in %) in Panama in 1970 to that in 2001?
Provide a succinct answer. 2.12. What is the ratio of the Value added (in %) of Philippines in 1970 to that in 2001?
Provide a succinct answer. 1.12. What is the ratio of the Value added (in %) in Sudan in 1970 to that in 2001?
Offer a terse response. 8.16. What is the ratio of the Value added (in %) of Belgium in 1971 to that in 1972?
Your answer should be very brief. 1. What is the ratio of the Value added (in %) of Panama in 1971 to that in 1972?
Make the answer very short. 0.93. What is the ratio of the Value added (in %) in Philippines in 1971 to that in 1972?
Give a very brief answer. 1.06. What is the ratio of the Value added (in %) in Sudan in 1971 to that in 1972?
Your answer should be very brief. 0.95. What is the ratio of the Value added (in %) of Belgium in 1971 to that in 1976?
Provide a succinct answer. 1.27. What is the ratio of the Value added (in %) of Philippines in 1971 to that in 1976?
Offer a very short reply. 0.88. What is the ratio of the Value added (in %) in Sudan in 1971 to that in 1976?
Ensure brevity in your answer.  1.37. What is the ratio of the Value added (in %) of Belgium in 1971 to that in 2001?
Provide a short and direct response. 2.29. What is the ratio of the Value added (in %) in Panama in 1971 to that in 2001?
Provide a succinct answer. 2.11. What is the ratio of the Value added (in %) in Philippines in 1971 to that in 2001?
Give a very brief answer. 1.22. What is the ratio of the Value added (in %) in Sudan in 1971 to that in 2001?
Offer a terse response. 8.15. What is the ratio of the Value added (in %) in Belgium in 1972 to that in 1976?
Keep it short and to the point. 1.28. What is the ratio of the Value added (in %) in Panama in 1972 to that in 1976?
Ensure brevity in your answer.  1.08. What is the ratio of the Value added (in %) in Philippines in 1972 to that in 1976?
Offer a terse response. 0.82. What is the ratio of the Value added (in %) of Sudan in 1972 to that in 1976?
Offer a terse response. 1.44. What is the ratio of the Value added (in %) of Belgium in 1972 to that in 2001?
Offer a very short reply. 2.3. What is the ratio of the Value added (in %) of Panama in 1972 to that in 2001?
Ensure brevity in your answer.  2.27. What is the ratio of the Value added (in %) in Philippines in 1972 to that in 2001?
Your answer should be compact. 1.14. What is the ratio of the Value added (in %) of Sudan in 1972 to that in 2001?
Provide a short and direct response. 8.58. What is the ratio of the Value added (in %) of Belgium in 1976 to that in 2001?
Keep it short and to the point. 1.8. What is the ratio of the Value added (in %) of Panama in 1976 to that in 2001?
Give a very brief answer. 2.1. What is the ratio of the Value added (in %) in Philippines in 1976 to that in 2001?
Provide a short and direct response. 1.39. What is the ratio of the Value added (in %) of Sudan in 1976 to that in 2001?
Your response must be concise. 5.94. What is the difference between the highest and the second highest Value added (in %) of Belgium?
Give a very brief answer. 1.33. What is the difference between the highest and the second highest Value added (in %) in Panama?
Give a very brief answer. 0.67. What is the difference between the highest and the second highest Value added (in %) in Philippines?
Ensure brevity in your answer.  0.76. What is the difference between the highest and the second highest Value added (in %) of Sudan?
Your response must be concise. 2.14. What is the difference between the highest and the lowest Value added (in %) of Belgium?
Make the answer very short. 9.63. What is the difference between the highest and the lowest Value added (in %) in Panama?
Your answer should be very brief. 5.34. What is the difference between the highest and the lowest Value added (in %) of Philippines?
Keep it short and to the point. 2.91. What is the difference between the highest and the lowest Value added (in %) of Sudan?
Keep it short and to the point. 34.27. 